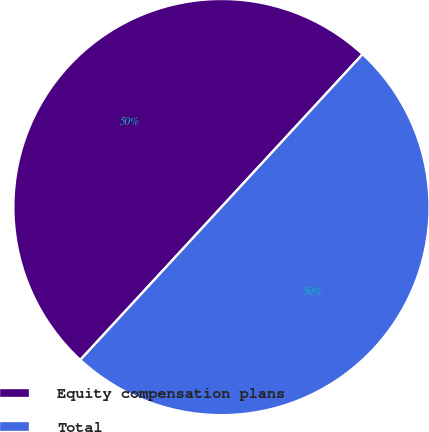Convert chart. <chart><loc_0><loc_0><loc_500><loc_500><pie_chart><fcel>Equity compensation plans<fcel>Total<nl><fcel>50.0%<fcel>50.0%<nl></chart> 